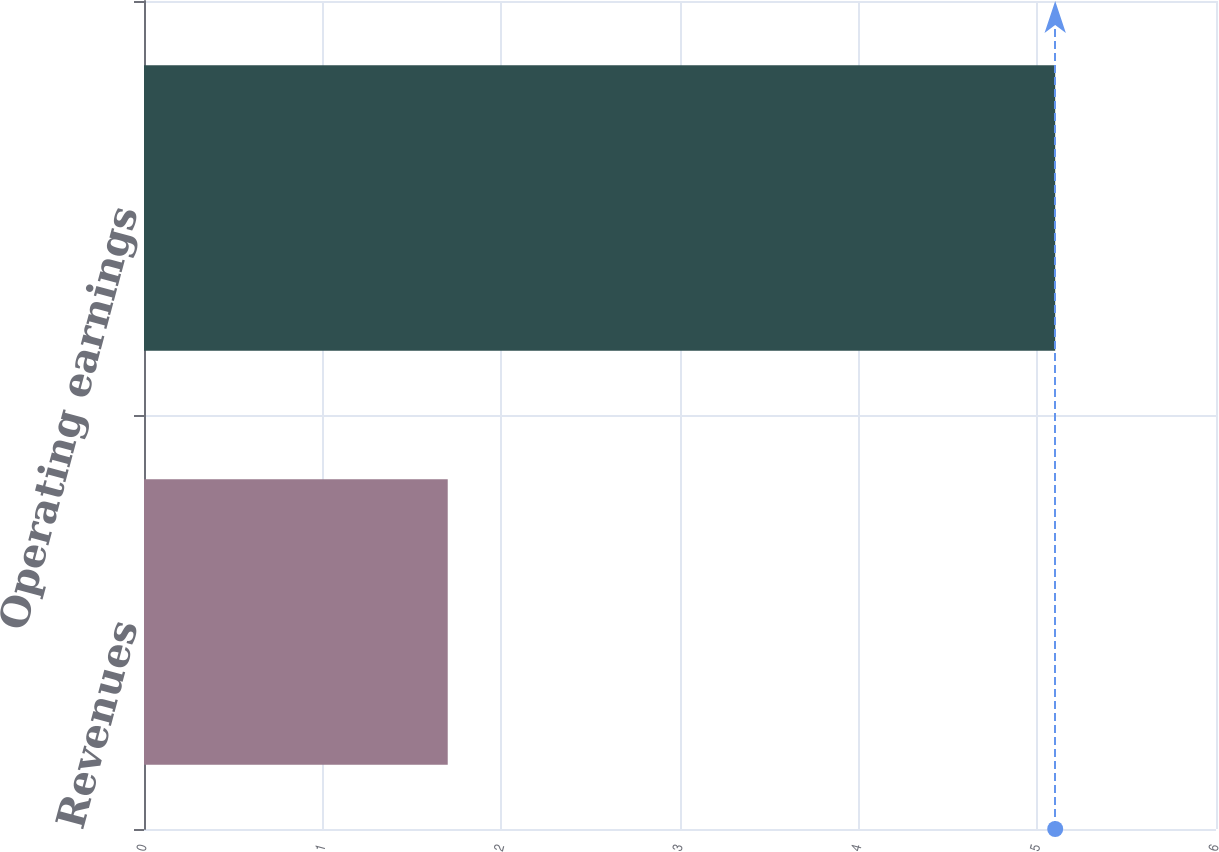<chart> <loc_0><loc_0><loc_500><loc_500><bar_chart><fcel>Revenues<fcel>Operating earnings<nl><fcel>1.7<fcel>5.1<nl></chart> 